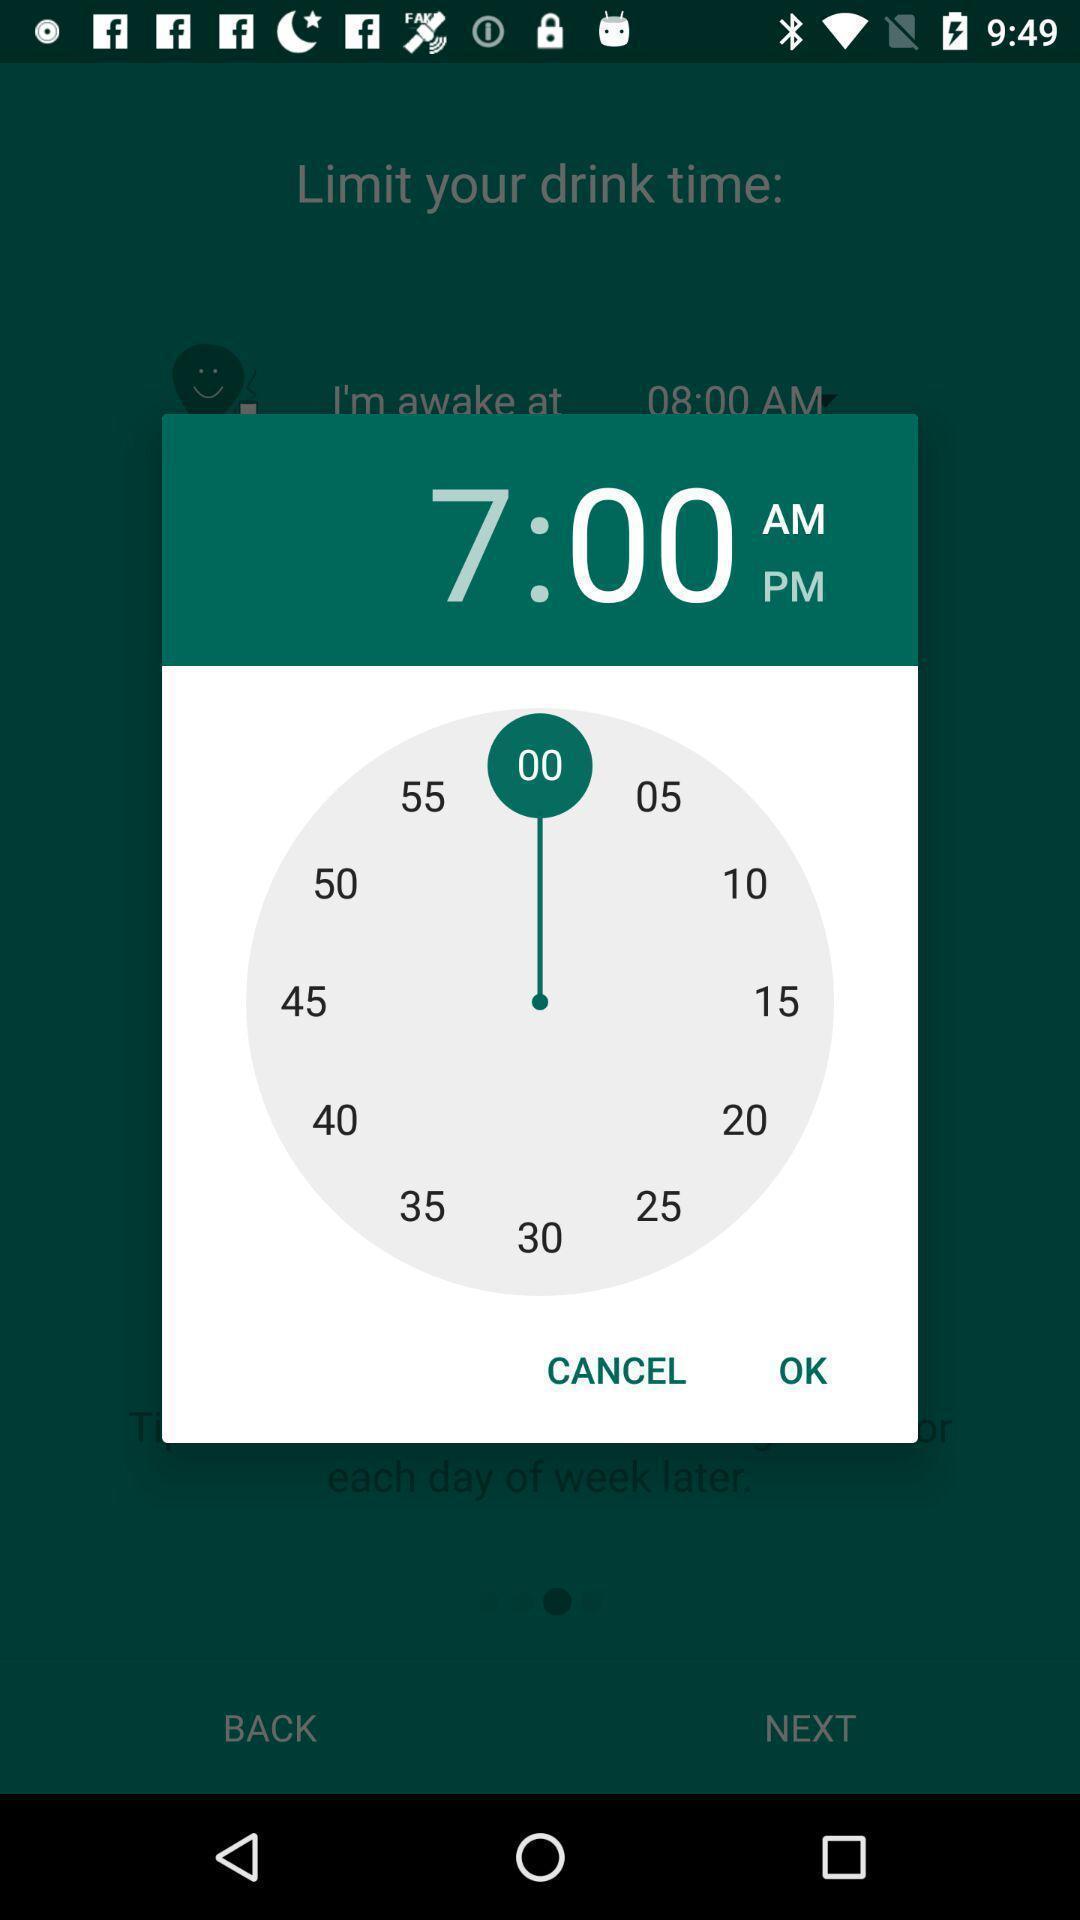Summarize the main components in this picture. Setting reminder for drinking water. 